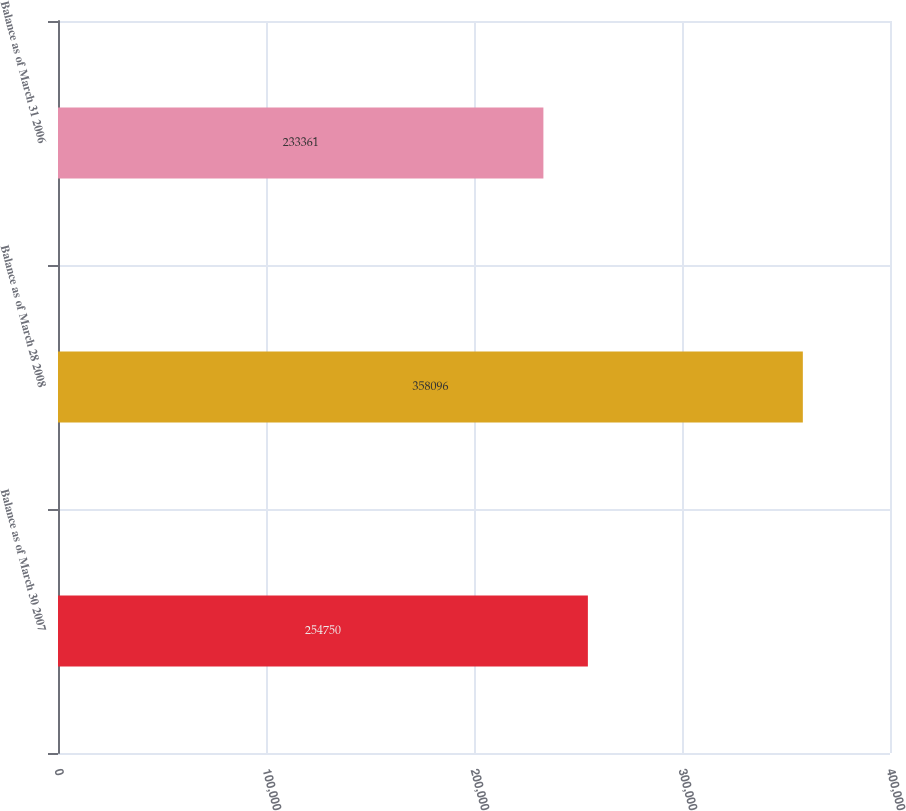Convert chart. <chart><loc_0><loc_0><loc_500><loc_500><bar_chart><fcel>Balance as of March 30 2007<fcel>Balance as of March 28 2008<fcel>Balance as of March 31 2006<nl><fcel>254750<fcel>358096<fcel>233361<nl></chart> 